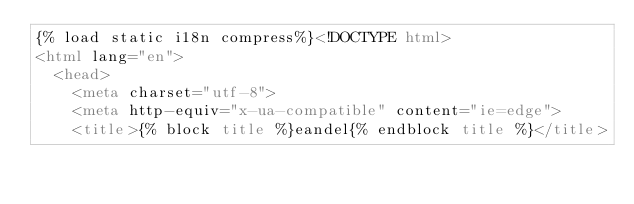Convert code to text. <code><loc_0><loc_0><loc_500><loc_500><_HTML_>{% load static i18n compress%}<!DOCTYPE html>
<html lang="en">
  <head>
    <meta charset="utf-8">
    <meta http-equiv="x-ua-compatible" content="ie=edge">
    <title>{% block title %}eandel{% endblock title %}</title></code> 